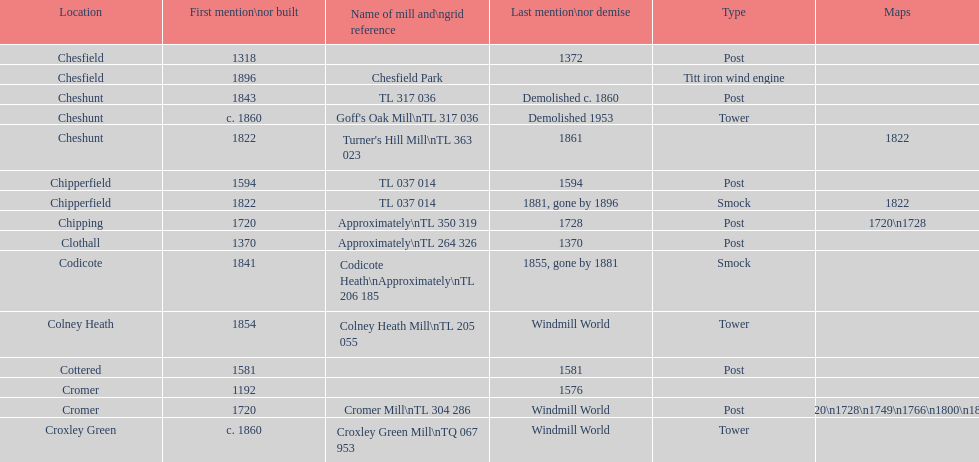How many mills were built or first mentioned after 1800? 8. I'm looking to parse the entire table for insights. Could you assist me with that? {'header': ['Location', 'First mention\\nor built', 'Name of mill and\\ngrid reference', 'Last mention\\nor demise', 'Type', 'Maps'], 'rows': [['Chesfield', '1318', '', '1372', 'Post', ''], ['Chesfield', '1896', 'Chesfield Park', '', 'Titt iron wind engine', ''], ['Cheshunt', '1843', 'TL 317 036', 'Demolished c. 1860', 'Post', ''], ['Cheshunt', 'c. 1860', "Goff's Oak Mill\\nTL 317 036", 'Demolished 1953', 'Tower', ''], ['Cheshunt', '1822', "Turner's Hill Mill\\nTL 363 023", '1861', '', '1822'], ['Chipperfield', '1594', 'TL 037 014', '1594', 'Post', ''], ['Chipperfield', '1822', 'TL 037 014', '1881, gone by 1896', 'Smock', '1822'], ['Chipping', '1720', 'Approximately\\nTL 350 319', '1728', 'Post', '1720\\n1728'], ['Clothall', '1370', 'Approximately\\nTL 264 326', '1370', 'Post', ''], ['Codicote', '1841', 'Codicote Heath\\nApproximately\\nTL 206 185', '1855, gone by 1881', 'Smock', ''], ['Colney Heath', '1854', 'Colney Heath Mill\\nTL 205 055', 'Windmill World', 'Tower', ''], ['Cottered', '1581', '', '1581', 'Post', ''], ['Cromer', '1192', '', '1576', '', ''], ['Cromer', '1720', 'Cromer Mill\\nTL 304 286', 'Windmill World', 'Post', '1720\\n1728\\n1749\\n1766\\n1800\\n1822'], ['Croxley Green', 'c. 1860', 'Croxley Green Mill\\nTQ 067 953', 'Windmill World', 'Tower', '']]} 